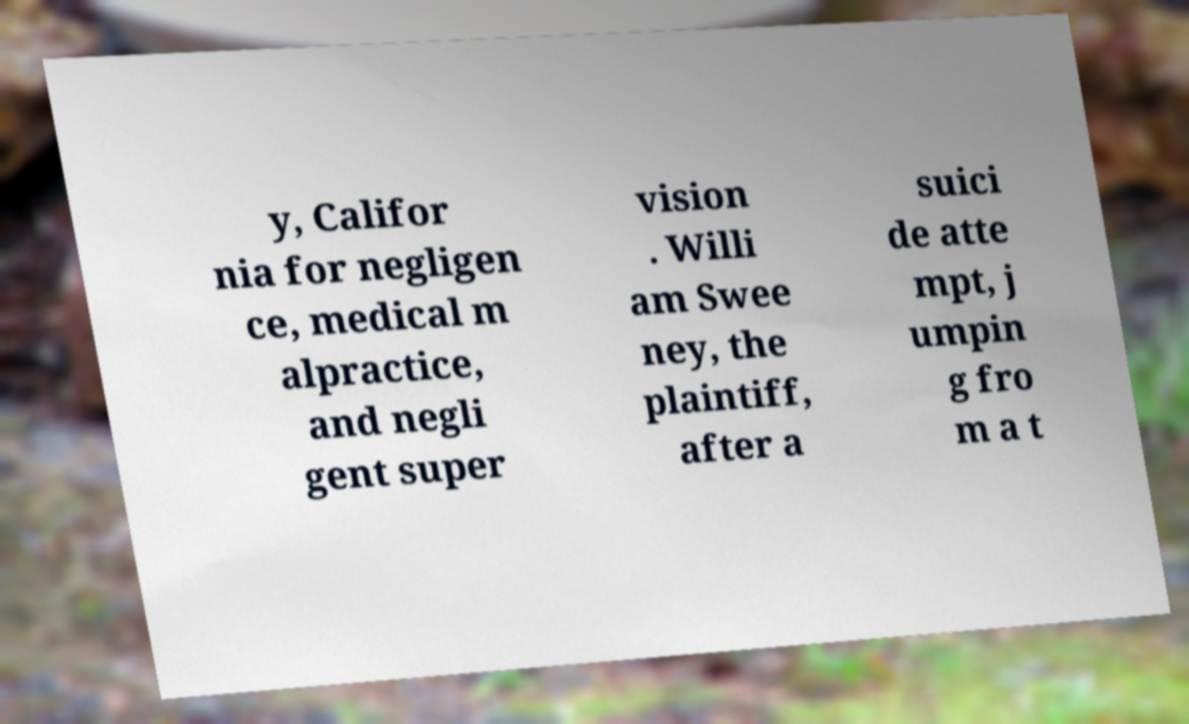I need the written content from this picture converted into text. Can you do that? y, Califor nia for negligen ce, medical m alpractice, and negli gent super vision . Willi am Swee ney, the plaintiff, after a suici de atte mpt, j umpin g fro m a t 